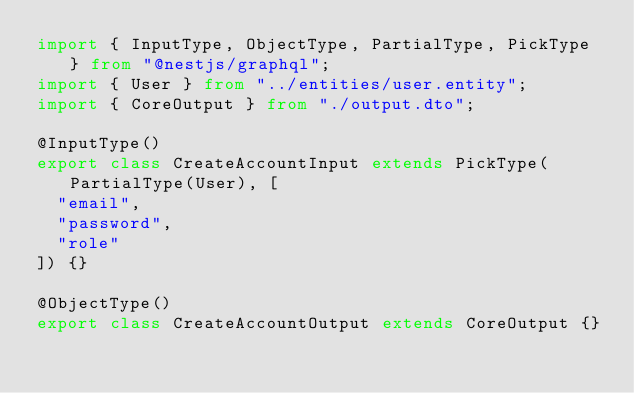Convert code to text. <code><loc_0><loc_0><loc_500><loc_500><_TypeScript_>import { InputType, ObjectType, PartialType, PickType } from "@nestjs/graphql";
import { User } from "../entities/user.entity";
import { CoreOutput } from "./output.dto";

@InputType()
export class CreateAccountInput extends PickType(PartialType(User), [
  "email",
  "password",
  "role"
]) {}

@ObjectType()
export class CreateAccountOutput extends CoreOutput {}
</code> 